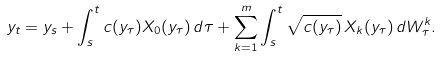Convert formula to latex. <formula><loc_0><loc_0><loc_500><loc_500>y _ { t } = y _ { s } + \int _ { s } ^ { t } c ( y _ { \tau } ) X _ { 0 } ( y _ { \tau } ) \, d \tau + \sum _ { k = 1 } ^ { m } \int _ { s } ^ { t } \sqrt { c ( y _ { \tau } ) } \, X _ { k } ( y _ { \tau } ) \, d W _ { \tau } ^ { k } .</formula> 